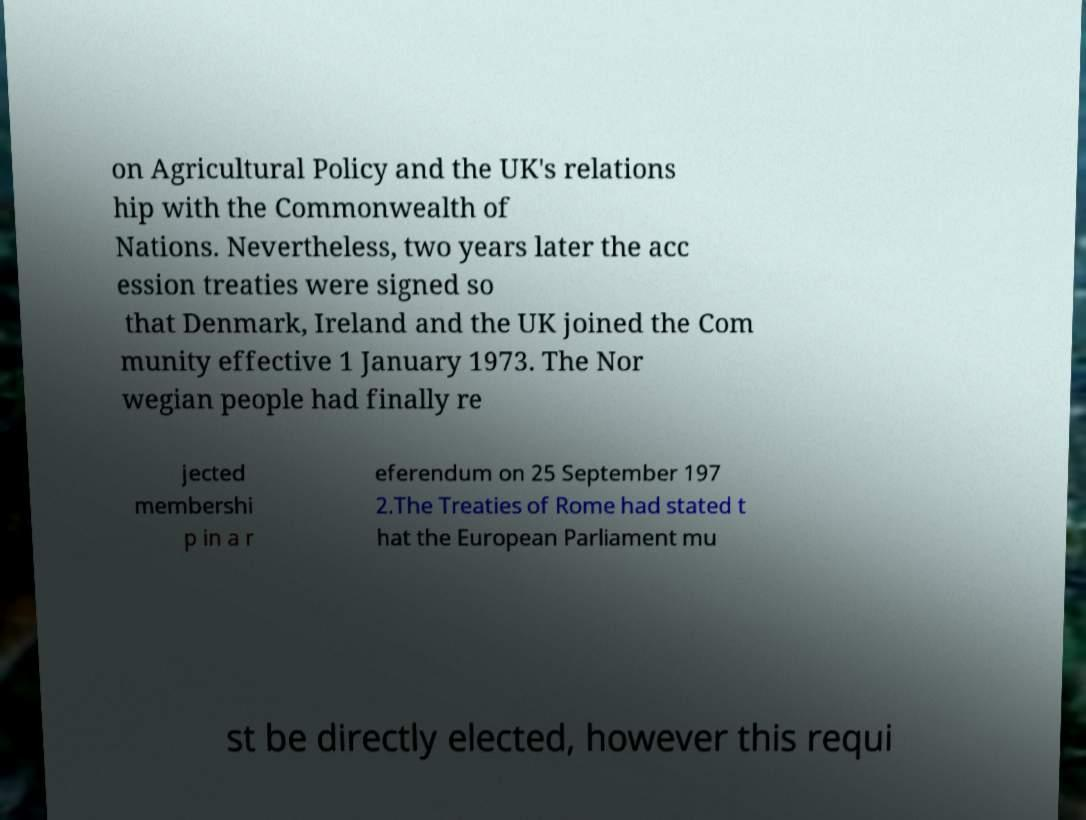Can you accurately transcribe the text from the provided image for me? on Agricultural Policy and the UK's relations hip with the Commonwealth of Nations. Nevertheless, two years later the acc ession treaties were signed so that Denmark, Ireland and the UK joined the Com munity effective 1 January 1973. The Nor wegian people had finally re jected membershi p in a r eferendum on 25 September 197 2.The Treaties of Rome had stated t hat the European Parliament mu st be directly elected, however this requi 